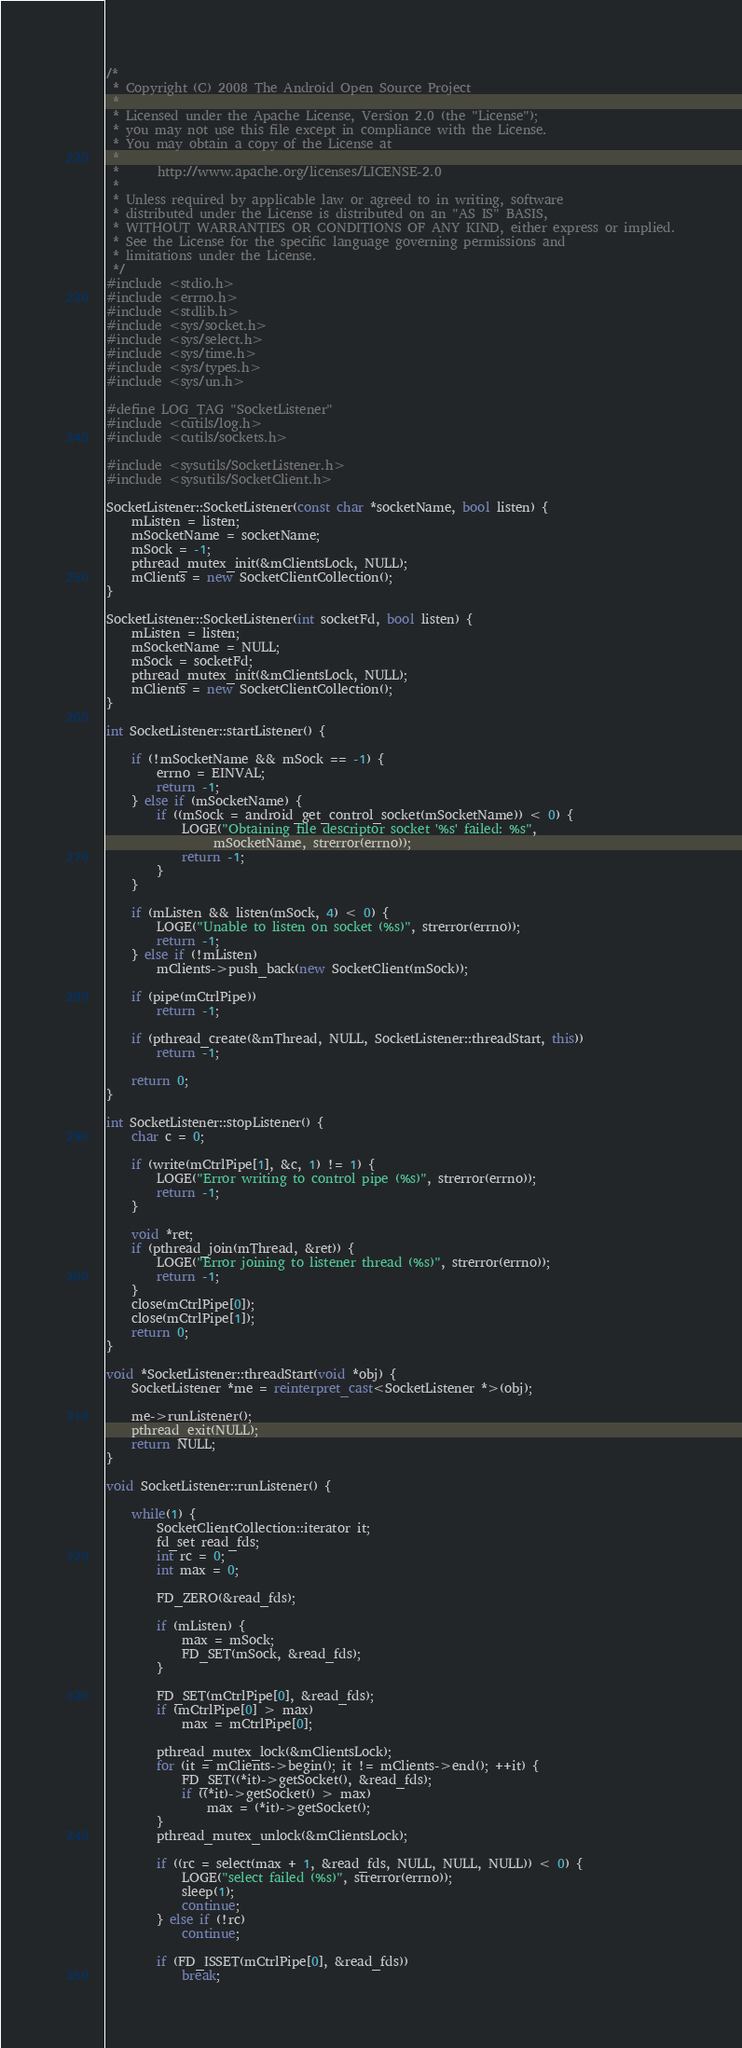Convert code to text. <code><loc_0><loc_0><loc_500><loc_500><_C++_>/*
 * Copyright (C) 2008 The Android Open Source Project
 *
 * Licensed under the Apache License, Version 2.0 (the "License");
 * you may not use this file except in compliance with the License.
 * You may obtain a copy of the License at
 *
 *      http://www.apache.org/licenses/LICENSE-2.0
 *
 * Unless required by applicable law or agreed to in writing, software
 * distributed under the License is distributed on an "AS IS" BASIS,
 * WITHOUT WARRANTIES OR CONDITIONS OF ANY KIND, either express or implied.
 * See the License for the specific language governing permissions and
 * limitations under the License.
 */
#include <stdio.h>
#include <errno.h>
#include <stdlib.h>
#include <sys/socket.h>
#include <sys/select.h>
#include <sys/time.h>
#include <sys/types.h>
#include <sys/un.h>

#define LOG_TAG "SocketListener"
#include <cutils/log.h>
#include <cutils/sockets.h>

#include <sysutils/SocketListener.h>
#include <sysutils/SocketClient.h>

SocketListener::SocketListener(const char *socketName, bool listen) {
    mListen = listen;
    mSocketName = socketName;
    mSock = -1;
    pthread_mutex_init(&mClientsLock, NULL);
    mClients = new SocketClientCollection();
}

SocketListener::SocketListener(int socketFd, bool listen) {
    mListen = listen;
    mSocketName = NULL;
    mSock = socketFd;
    pthread_mutex_init(&mClientsLock, NULL);
    mClients = new SocketClientCollection();
}

int SocketListener::startListener() {

    if (!mSocketName && mSock == -1) {
        errno = EINVAL;
        return -1;
    } else if (mSocketName) {
        if ((mSock = android_get_control_socket(mSocketName)) < 0) {
            LOGE("Obtaining file descriptor socket '%s' failed: %s",
                 mSocketName, strerror(errno));
            return -1;
        }
    }

    if (mListen && listen(mSock, 4) < 0) {
        LOGE("Unable to listen on socket (%s)", strerror(errno));
        return -1;
    } else if (!mListen)
        mClients->push_back(new SocketClient(mSock));

    if (pipe(mCtrlPipe))
        return -1;

    if (pthread_create(&mThread, NULL, SocketListener::threadStart, this))
        return -1;

    return 0;
}

int SocketListener::stopListener() {
    char c = 0;

    if (write(mCtrlPipe[1], &c, 1) != 1) {
        LOGE("Error writing to control pipe (%s)", strerror(errno));
        return -1;
    }

    void *ret;
    if (pthread_join(mThread, &ret)) {
        LOGE("Error joining to listener thread (%s)", strerror(errno));
        return -1;
    }
    close(mCtrlPipe[0]);
    close(mCtrlPipe[1]);
    return 0;
}

void *SocketListener::threadStart(void *obj) {
    SocketListener *me = reinterpret_cast<SocketListener *>(obj);

    me->runListener();
    pthread_exit(NULL);
    return NULL;
}

void SocketListener::runListener() {

    while(1) {
        SocketClientCollection::iterator it;
        fd_set read_fds;
        int rc = 0;
        int max = 0;

        FD_ZERO(&read_fds);

        if (mListen) {
            max = mSock;
            FD_SET(mSock, &read_fds);
        }

        FD_SET(mCtrlPipe[0], &read_fds);
        if (mCtrlPipe[0] > max)
            max = mCtrlPipe[0];

        pthread_mutex_lock(&mClientsLock);
        for (it = mClients->begin(); it != mClients->end(); ++it) {
            FD_SET((*it)->getSocket(), &read_fds);
            if ((*it)->getSocket() > max)
                max = (*it)->getSocket();
        }
        pthread_mutex_unlock(&mClientsLock);

        if ((rc = select(max + 1, &read_fds, NULL, NULL, NULL)) < 0) {
            LOGE("select failed (%s)", strerror(errno));
            sleep(1);
            continue;
        } else if (!rc)
            continue;

        if (FD_ISSET(mCtrlPipe[0], &read_fds))
            break;</code> 